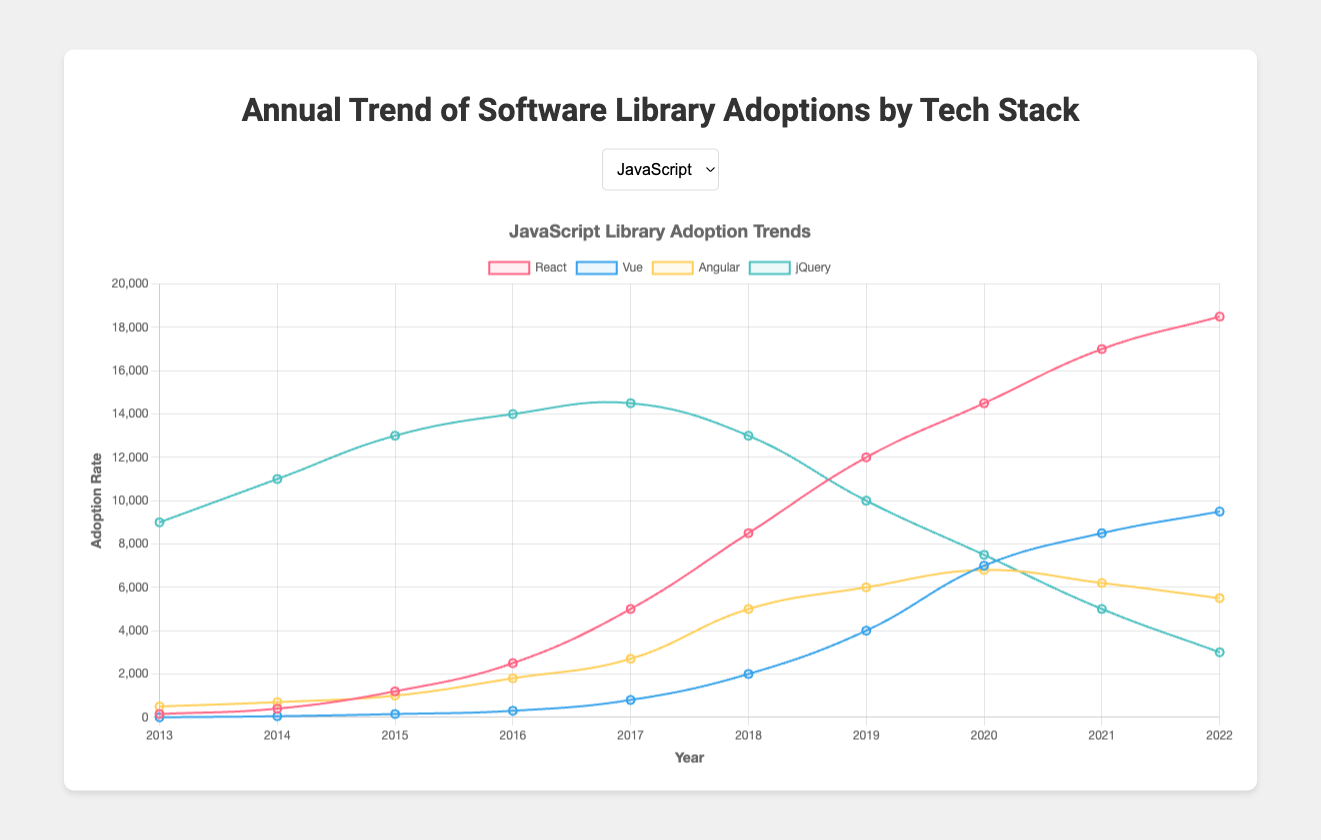Which JavaScript library had the highest adoption in 2022? Observing the JavaScript stack for 2022, React has the highest value on the y-axis compared to other libraries.
Answer: React Between 2016 and 2018, which Python library showed the greatest increase in adoption? Calculate the increase in adoption for each library between 2016 and 2018: Django (4500 to 6000, increase = 1500), Flask (2000 to 4500, increase = 2500), Pandas (3500 to 6500, increase = 3000), TensorFlow (50 to 2000, increase = 1950). Pandas has the largest increase at 3000.
Answer: Pandas Compare the adoption trends of jQuery and React from 2013 to 2022. Which library had a significant decline? By visual inspection: jQuery decreases gradually from 9000 to 3000, while React significantly increases from 150 to 18500. Thus, jQuery had a significant decline.
Answer: jQuery Which year did TensorFlow first appear in the dataset, and what was its adoption rate? TensorFlow first appears in the year 2016 and the adoption rate is at 50.
Answer: 2016, 50 Comparing the highest values, which has a greater peak adoption: Vue or Django? Vue's highest value is 9500 in 2022 and Django's highest value is 8000 in 2022. Thus, Vue has the greater peak adoption.
Answer: Vue What is the trend for the Rails library from 2013 to 2022? Is it increasing or decreasing? Observing the Rails line, it generally increases until 2018 peaking at 7500, then declines to 6900 by 2022.
Answer: Increasing until 2018, then decreasing Which Java library had steady growth over the years with no significant fluctuations? By examining the trends, Hibernate shows a relatively steady growth from 1800 in 2013 to 4400 in 2022 without significant fluctuations.
Answer: Hibernate In 2020, which PHP library had the highest adoption rate? By examining the PHP stack for 2020, Laravel has the highest adoption rate with 4600.
Answer: Laravel What was the adoption rate of Angular in 2017, and how does it compare to Vue's adoption rate in the same year? Angular's adoption rate in 2017 is 2700; Vue's adoption rate in 2017 is 800. Thus, Angular's rate is higher than Vue's.
Answer: Angular 2700, higher than Vue Which Python library witnessed the sharpest growth after its introduction? TensorFlow first appears in 2016 with 50 and quickly rises to 10500 by 2022, indicating the sharpest growth after introduction among Python libraries.
Answer: TensorFlow 